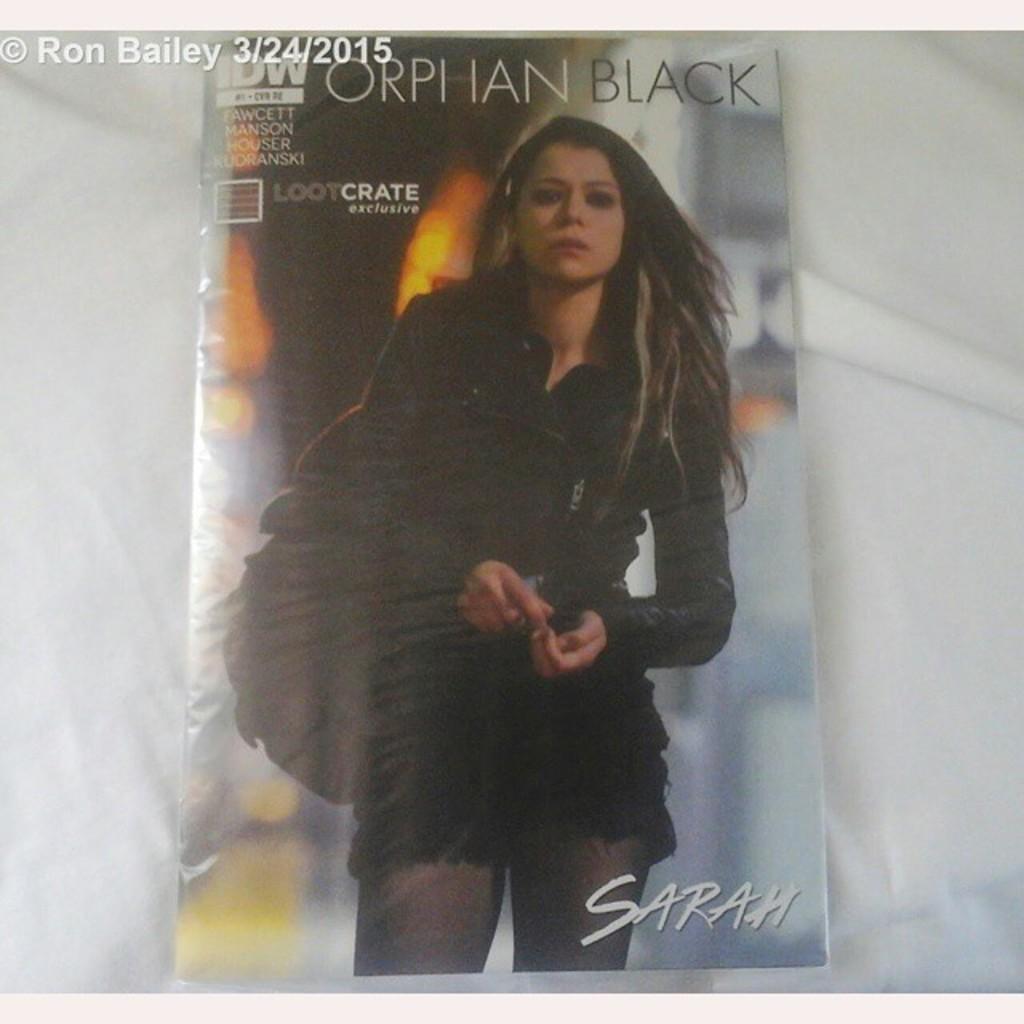Please provide a concise description of this image. In this image a magazine is kept on a cloth. On the cover of the magazine a lady wearing black dress is there. 